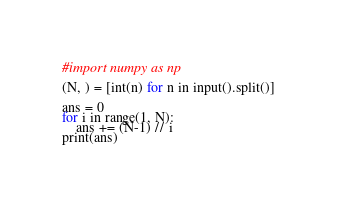<code> <loc_0><loc_0><loc_500><loc_500><_Python_>#import numpy as np

(N, ) = [int(n) for n in input().split()]

ans = 0
for i in range(1, N):
    ans += (N-1) // i
print(ans)


</code> 